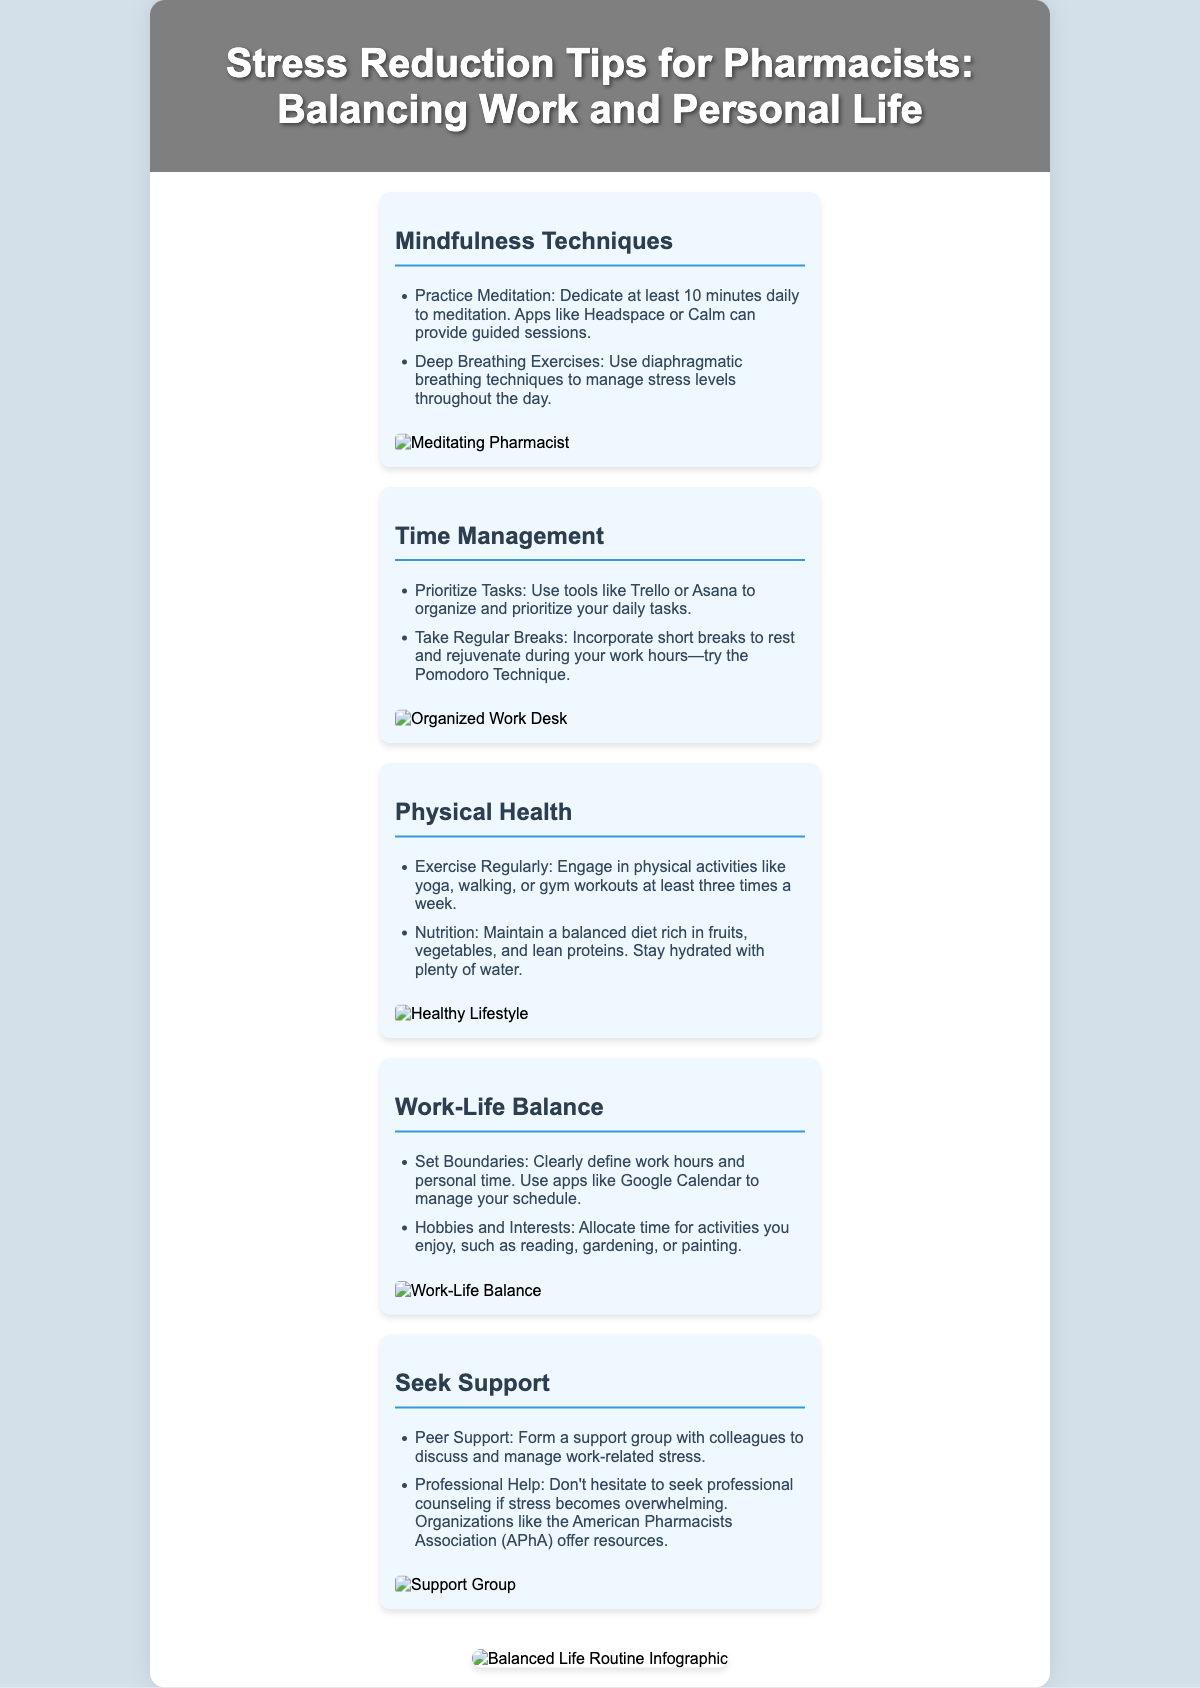what is the main title of the poster? The title located in the header of the poster is fundamental to understanding its content and purpose.
Answer: Stress Reduction Tips for Pharmacists: Balancing Work and Personal Life how many mindfulness techniques are listed? The section on mindfulness techniques contains a list that can be counted to determine how many specific suggestions are provided.
Answer: 2 what is one tool recommended for time management? The document includes various suggestions for time management, highlighting specific tools that help organize tasks effectively.
Answer: Trello what type of exercise is suggested for physical health? The section dedicated to physical health mentions various kinds of exercise to promote well-being, thus pointing to what is encouraged.
Answer: Yoga name one way to seek support mentioned in the document. The document explicitly outlines methods for pharmacists to find support, clarifying available avenues for assistance.
Answer: Peer Support which infographic is included in the poster? Identifying the infographic included helps summarize the key message or concept visually presented within the document.
Answer: Balanced Life Routine Infographic how many sections are there in the content? The content is divided into distinct areas, and counting them reveals the organization of the information provided.
Answer: 5 what color theme is used in the background? The document describes the overall style and color scheme, which contributes to the peaceful ambiance intended for the viewer.
Answer: Soft pastel who provides professional help resources according to the poster? The document indicates specific organizations known to offer resources for professional assistance when needed.
Answer: American Pharmacists Association (APhA) 